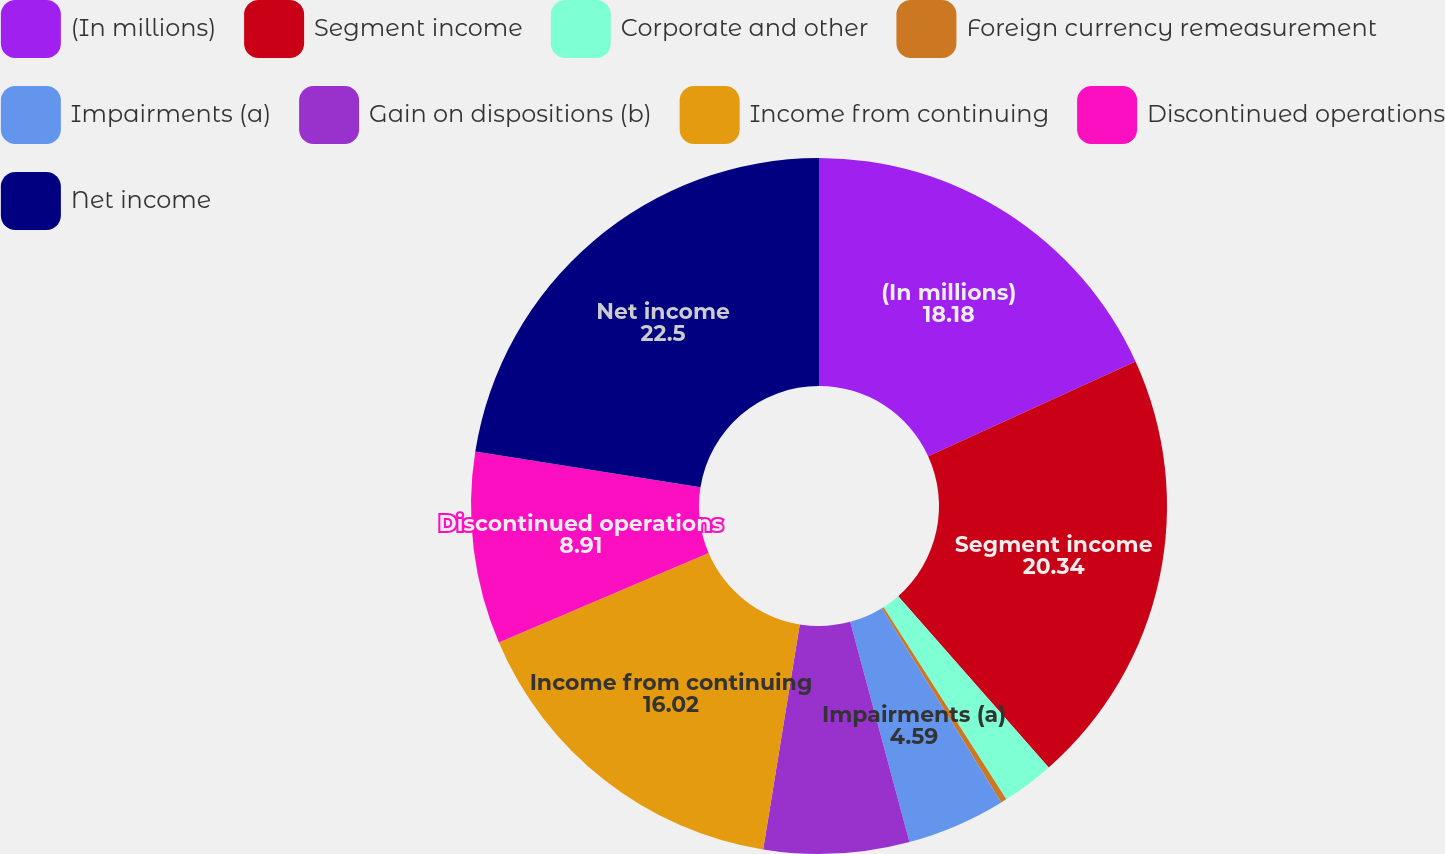Convert chart to OTSL. <chart><loc_0><loc_0><loc_500><loc_500><pie_chart><fcel>(In millions)<fcel>Segment income<fcel>Corporate and other<fcel>Foreign currency remeasurement<fcel>Impairments (a)<fcel>Gain on dispositions (b)<fcel>Income from continuing<fcel>Discontinued operations<fcel>Net income<nl><fcel>18.18%<fcel>20.34%<fcel>2.43%<fcel>0.27%<fcel>4.59%<fcel>6.75%<fcel>16.02%<fcel>8.91%<fcel>22.5%<nl></chart> 